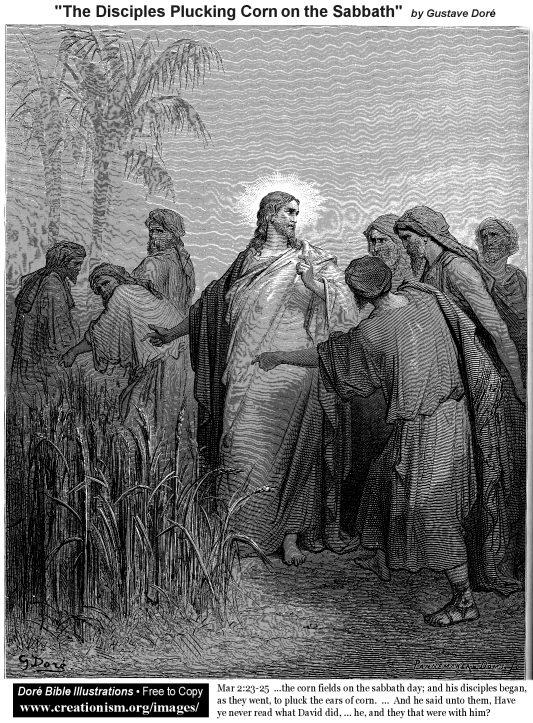What is the historical context of this scene? This illustration by Gustave Doré depicts a scene from the New Testament where Jesus Christ and His disciples pluck corn on the Sabbath, a day traditionally reserved for rest in Jewish law. The Pharisees questioned this act as it was considered a form of work, to which Jesus responded by referencing David's actions when he ate the consecrated bread out of hunger. This story highlights the themes of compassion and necessity over strict adherence to law. Can you describe the artistic style used in this illustration? Gustave Doré's illustration employs a highly realistic art style characterized by detailed line work and extensive use of cross-hatching for shading. The monochromatic palette of black and white emphasizes contrast and enhances the dramatic effect of the scene. The meticulous details, such as the textures of the disciples' robes and the cornfield, showcase Doré's skill in creating depth and realism within a limited color scheme. 